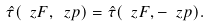<formula> <loc_0><loc_0><loc_500><loc_500>\hat { \tau } ( \ z F , \ z p ) = \hat { \tau } ( \ z F , - \ z p ) .</formula> 